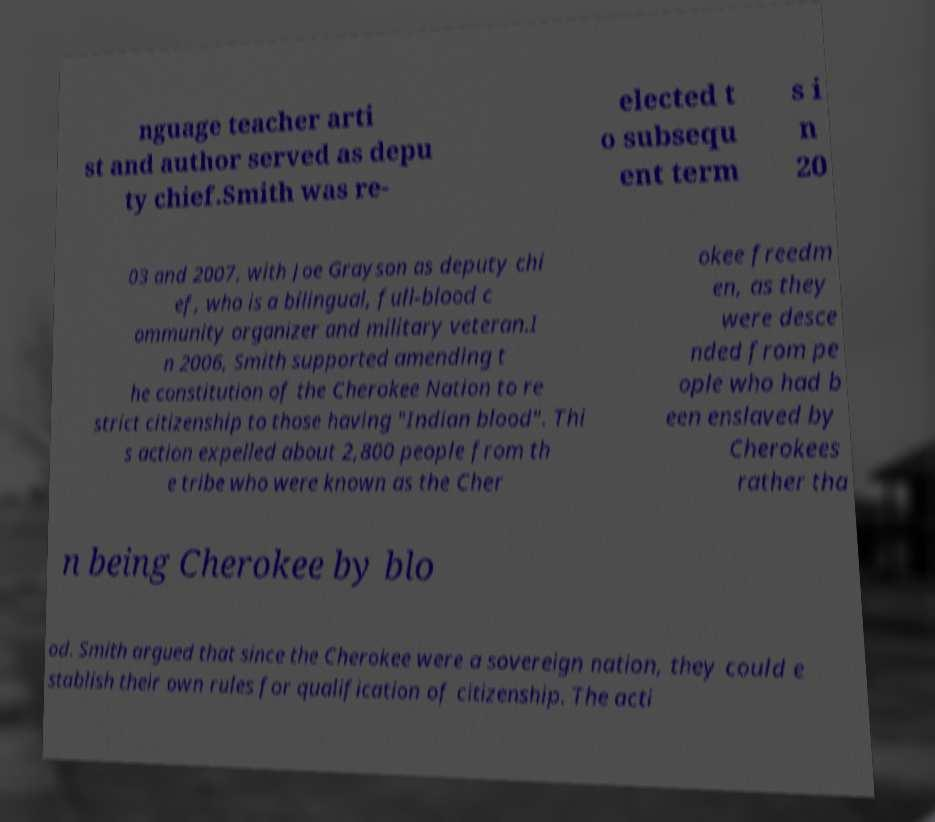Could you assist in decoding the text presented in this image and type it out clearly? nguage teacher arti st and author served as depu ty chief.Smith was re- elected t o subsequ ent term s i n 20 03 and 2007, with Joe Grayson as deputy chi ef, who is a bilingual, full-blood c ommunity organizer and military veteran.I n 2006, Smith supported amending t he constitution of the Cherokee Nation to re strict citizenship to those having "Indian blood". Thi s action expelled about 2,800 people from th e tribe who were known as the Cher okee freedm en, as they were desce nded from pe ople who had b een enslaved by Cherokees rather tha n being Cherokee by blo od. Smith argued that since the Cherokee were a sovereign nation, they could e stablish their own rules for qualification of citizenship. The acti 